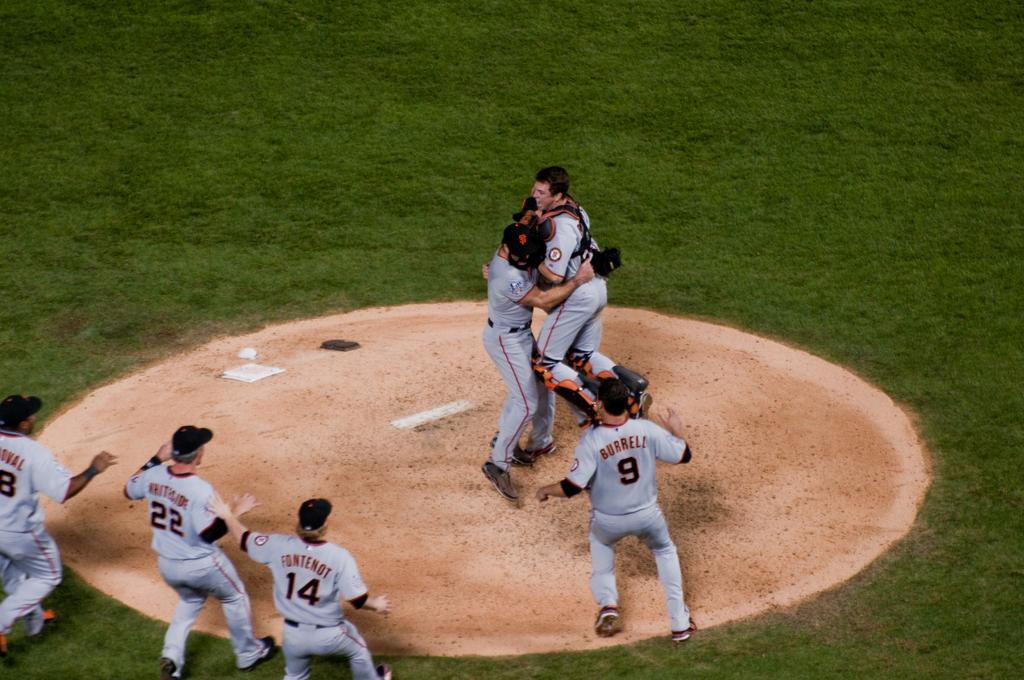<image>
Summarize the visual content of the image. Number 9 Burrell amongst others watch their baseball team mates celebrate on the pitchers mound. 